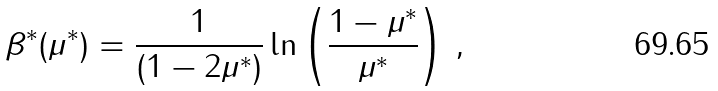Convert formula to latex. <formula><loc_0><loc_0><loc_500><loc_500>\beta ^ { \ast } ( \mu ^ { \ast } ) = \frac { 1 } { ( 1 - 2 \mu ^ { \ast } ) } \ln \left ( \frac { 1 - \mu ^ { \ast } } { \mu ^ { \ast } } \right ) \, ,</formula> 